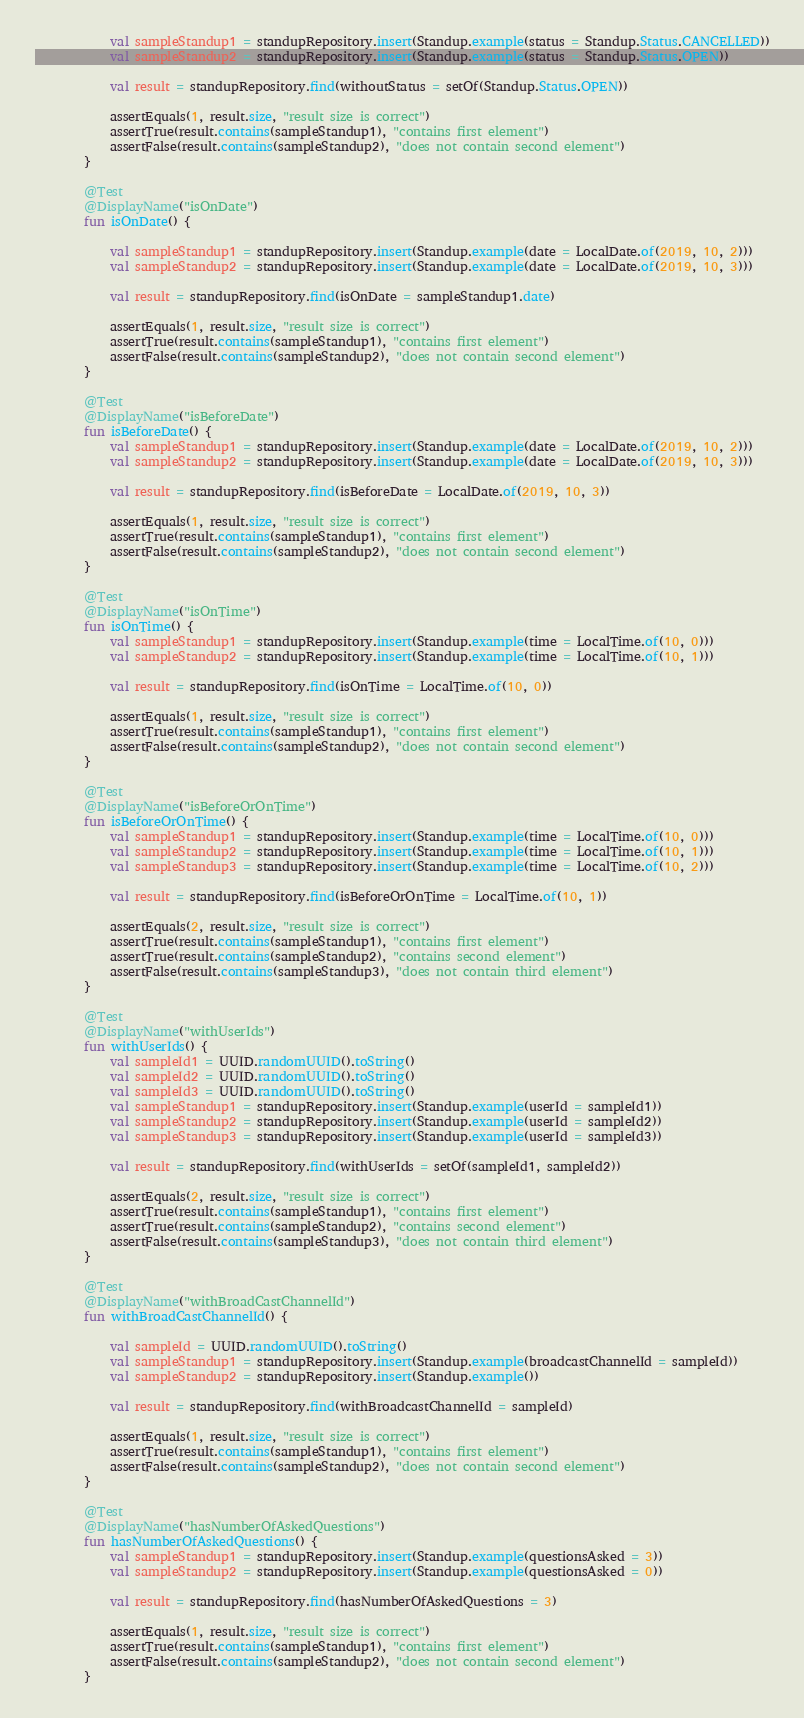Convert code to text. <code><loc_0><loc_0><loc_500><loc_500><_Kotlin_>            val sampleStandup1 = standupRepository.insert(Standup.example(status = Standup.Status.CANCELLED))
            val sampleStandup2 = standupRepository.insert(Standup.example(status = Standup.Status.OPEN))

            val result = standupRepository.find(withoutStatus = setOf(Standup.Status.OPEN))

            assertEquals(1, result.size, "result size is correct")
            assertTrue(result.contains(sampleStandup1), "contains first element")
            assertFalse(result.contains(sampleStandup2), "does not contain second element")
        }

        @Test
        @DisplayName("isOnDate")
        fun isOnDate() {

            val sampleStandup1 = standupRepository.insert(Standup.example(date = LocalDate.of(2019, 10, 2)))
            val sampleStandup2 = standupRepository.insert(Standup.example(date = LocalDate.of(2019, 10, 3)))

            val result = standupRepository.find(isOnDate = sampleStandup1.date)

            assertEquals(1, result.size, "result size is correct")
            assertTrue(result.contains(sampleStandup1), "contains first element")
            assertFalse(result.contains(sampleStandup2), "does not contain second element")
        }

        @Test
        @DisplayName("isBeforeDate")
        fun isBeforeDate() {
            val sampleStandup1 = standupRepository.insert(Standup.example(date = LocalDate.of(2019, 10, 2)))
            val sampleStandup2 = standupRepository.insert(Standup.example(date = LocalDate.of(2019, 10, 3)))

            val result = standupRepository.find(isBeforeDate = LocalDate.of(2019, 10, 3))

            assertEquals(1, result.size, "result size is correct")
            assertTrue(result.contains(sampleStandup1), "contains first element")
            assertFalse(result.contains(sampleStandup2), "does not contain second element")
        }

        @Test
        @DisplayName("isOnTime")
        fun isOnTime() {
            val sampleStandup1 = standupRepository.insert(Standup.example(time = LocalTime.of(10, 0)))
            val sampleStandup2 = standupRepository.insert(Standup.example(time = LocalTime.of(10, 1)))

            val result = standupRepository.find(isOnTime = LocalTime.of(10, 0))

            assertEquals(1, result.size, "result size is correct")
            assertTrue(result.contains(sampleStandup1), "contains first element")
            assertFalse(result.contains(sampleStandup2), "does not contain second element")
        }

        @Test
        @DisplayName("isBeforeOrOnTime")
        fun isBeforeOrOnTime() {
            val sampleStandup1 = standupRepository.insert(Standup.example(time = LocalTime.of(10, 0)))
            val sampleStandup2 = standupRepository.insert(Standup.example(time = LocalTime.of(10, 1)))
            val sampleStandup3 = standupRepository.insert(Standup.example(time = LocalTime.of(10, 2)))

            val result = standupRepository.find(isBeforeOrOnTime = LocalTime.of(10, 1))

            assertEquals(2, result.size, "result size is correct")
            assertTrue(result.contains(sampleStandup1), "contains first element")
            assertTrue(result.contains(sampleStandup2), "contains second element")
            assertFalse(result.contains(sampleStandup3), "does not contain third element")
        }

        @Test
        @DisplayName("withUserIds")
        fun withUserIds() {
            val sampleId1 = UUID.randomUUID().toString()
            val sampleId2 = UUID.randomUUID().toString()
            val sampleId3 = UUID.randomUUID().toString()
            val sampleStandup1 = standupRepository.insert(Standup.example(userId = sampleId1))
            val sampleStandup2 = standupRepository.insert(Standup.example(userId = sampleId2))
            val sampleStandup3 = standupRepository.insert(Standup.example(userId = sampleId3))

            val result = standupRepository.find(withUserIds = setOf(sampleId1, sampleId2))

            assertEquals(2, result.size, "result size is correct")
            assertTrue(result.contains(sampleStandup1), "contains first element")
            assertTrue(result.contains(sampleStandup2), "contains second element")
            assertFalse(result.contains(sampleStandup3), "does not contain third element")
        }

        @Test
        @DisplayName("withBroadCastChannelId")
        fun withBroadCastChannelId() {

            val sampleId = UUID.randomUUID().toString()
            val sampleStandup1 = standupRepository.insert(Standup.example(broadcastChannelId = sampleId))
            val sampleStandup2 = standupRepository.insert(Standup.example())

            val result = standupRepository.find(withBroadcastChannelId = sampleId)

            assertEquals(1, result.size, "result size is correct")
            assertTrue(result.contains(sampleStandup1), "contains first element")
            assertFalse(result.contains(sampleStandup2), "does not contain second element")
        }

        @Test
        @DisplayName("hasNumberOfAskedQuestions")
        fun hasNumberOfAskedQuestions() {
            val sampleStandup1 = standupRepository.insert(Standup.example(questionsAsked = 3))
            val sampleStandup2 = standupRepository.insert(Standup.example(questionsAsked = 0))

            val result = standupRepository.find(hasNumberOfAskedQuestions = 3)

            assertEquals(1, result.size, "result size is correct")
            assertTrue(result.contains(sampleStandup1), "contains first element")
            assertFalse(result.contains(sampleStandup2), "does not contain second element")
        }
</code> 